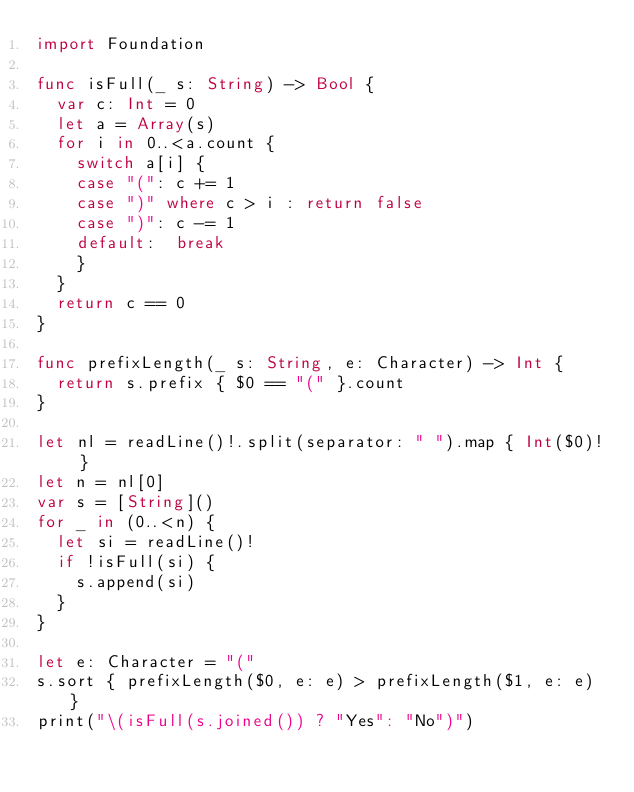<code> <loc_0><loc_0><loc_500><loc_500><_Swift_>import Foundation

func isFull(_ s: String) -> Bool {
  var c: Int = 0
  let a = Array(s)
  for i in 0..<a.count {
    switch a[i] {
    case "(": c += 1
    case ")" where c > i : return false
    case ")": c -= 1
    default:  break
    }
  }
  return c == 0
}

func prefixLength(_ s: String, e: Character) -> Int {
  return s.prefix { $0 == "(" }.count
}

let nl = readLine()!.split(separator: " ").map { Int($0)! }
let n = nl[0]
var s = [String]()
for _ in (0..<n) {
  let si = readLine()!
  if !isFull(si) {
    s.append(si)
  }
}

let e: Character = "("
s.sort { prefixLength($0, e: e) > prefixLength($1, e: e) }
print("\(isFull(s.joined()) ? "Yes": "No")")</code> 